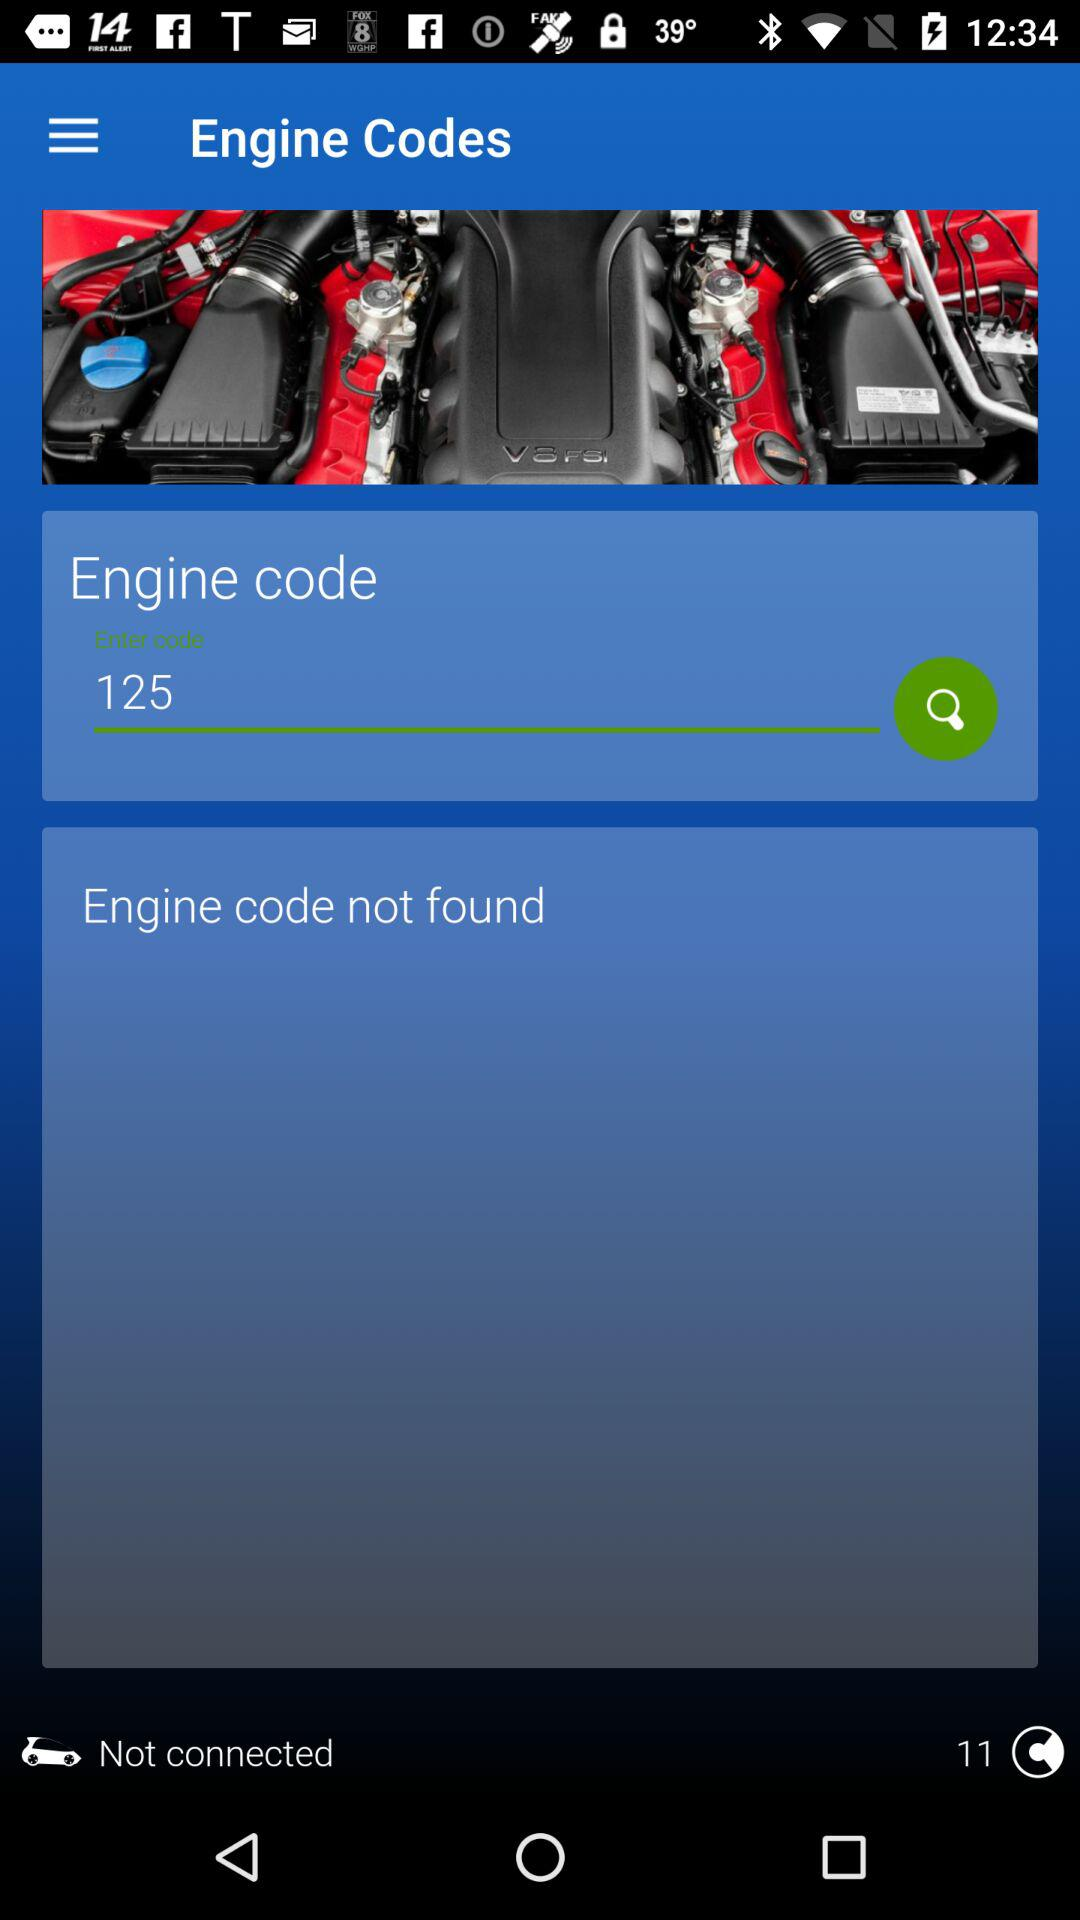When was the engine code search performed?
When the provided information is insufficient, respond with <no answer>. <no answer> 